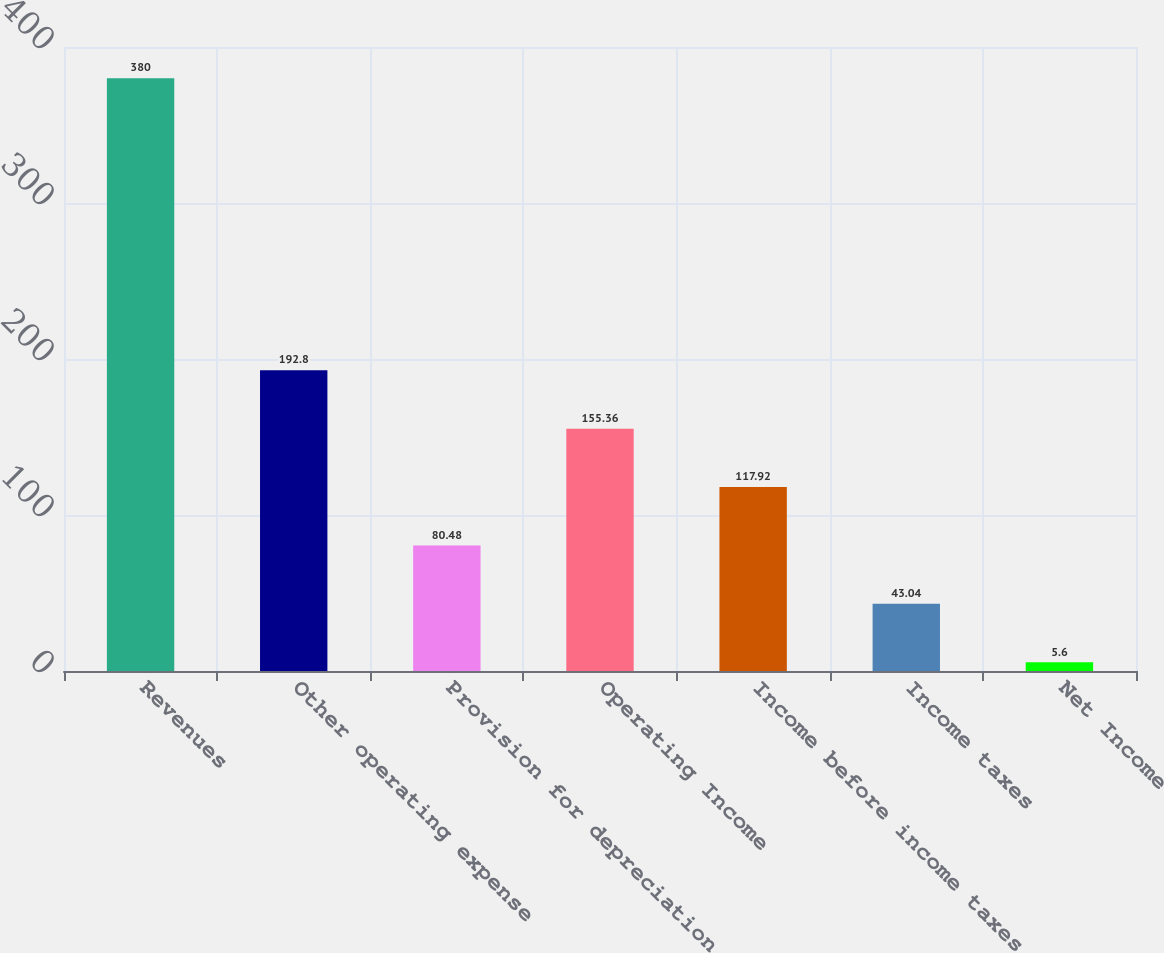Convert chart to OTSL. <chart><loc_0><loc_0><loc_500><loc_500><bar_chart><fcel>Revenues<fcel>Other operating expense<fcel>Provision for depreciation<fcel>Operating Income<fcel>Income before income taxes<fcel>Income taxes<fcel>Net Income<nl><fcel>380<fcel>192.8<fcel>80.48<fcel>155.36<fcel>117.92<fcel>43.04<fcel>5.6<nl></chart> 